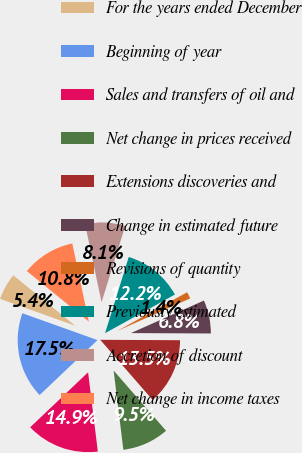Convert chart. <chart><loc_0><loc_0><loc_500><loc_500><pie_chart><fcel>For the years ended December<fcel>Beginning of year<fcel>Sales and transfers of oil and<fcel>Net change in prices received<fcel>Extensions discoveries and<fcel>Change in estimated future<fcel>Revisions of quantity<fcel>Previously estimated<fcel>Accretion of discount<fcel>Net change in income taxes<nl><fcel>5.41%<fcel>17.55%<fcel>14.86%<fcel>9.46%<fcel>13.51%<fcel>6.76%<fcel>1.37%<fcel>12.16%<fcel>8.11%<fcel>10.81%<nl></chart> 